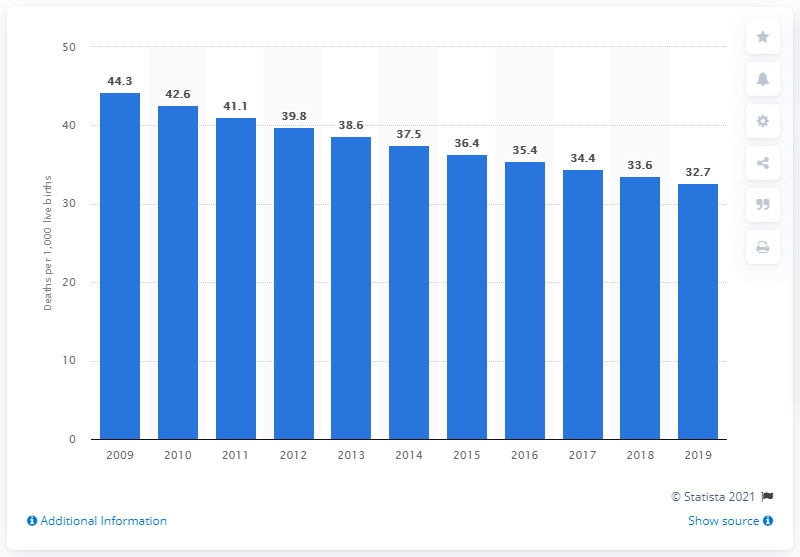Indicate a few pertinent items in this graphic. In 2019, the infant mortality rate in Senegal was 32.7 deaths per 1,000 live births. 